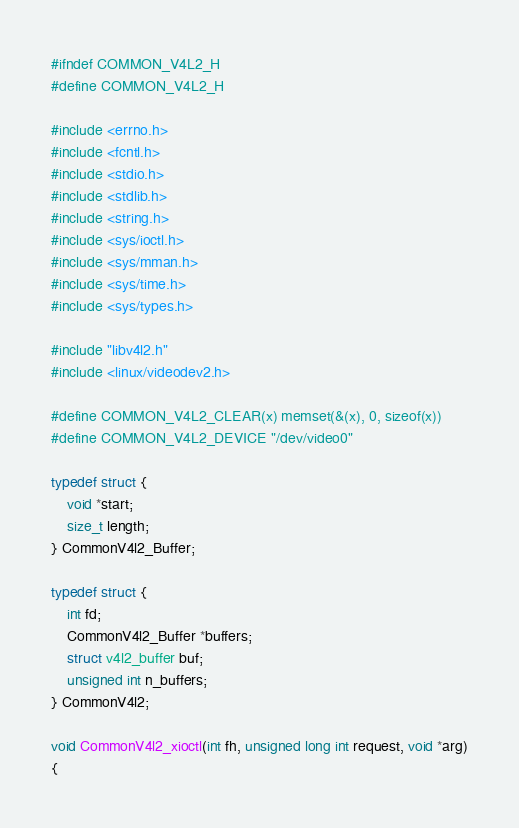Convert code to text. <code><loc_0><loc_0><loc_500><loc_500><_C_>#ifndef COMMON_V4L2_H
#define COMMON_V4L2_H

#include <errno.h>
#include <fcntl.h>
#include <stdio.h>
#include <stdlib.h>
#include <string.h>
#include <sys/ioctl.h>
#include <sys/mman.h>
#include <sys/time.h>
#include <sys/types.h>

#include "libv4l2.h"
#include <linux/videodev2.h>

#define COMMON_V4L2_CLEAR(x) memset(&(x), 0, sizeof(x))
#define COMMON_V4L2_DEVICE "/dev/video0"

typedef struct {
    void *start;
    size_t length;
} CommonV4l2_Buffer;

typedef struct {
    int fd;
    CommonV4l2_Buffer *buffers;
    struct v4l2_buffer buf;
    unsigned int n_buffers;
} CommonV4l2;

void CommonV4l2_xioctl(int fh, unsigned long int request, void *arg)
{</code> 